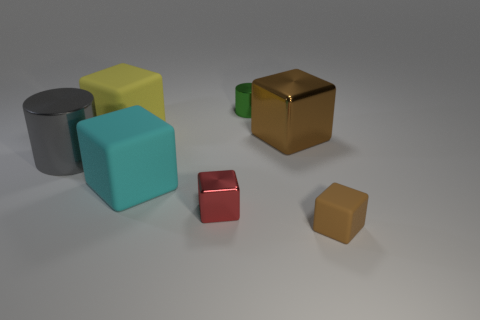Could you infer any purpose or context in which these objects might be used based on their appearance? Given their simple geometric shapes and smooth finishes, these objects might be used as educational tools for teaching shapes and colors to children, as part of a visualization in a 3D modeling software tutorial, or as design elements in a minimalist art installation.  If these objects were part of a game, what kind of game do you imagine it being? If these objects were part of a game, it could be a spatial reasoning puzzle where the goal is to fit the shapes into a specific pattern or sequence. Alternatively, it might be a tabletop game that requires players to stack or balance the objects according to specific rules. 